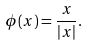<formula> <loc_0><loc_0><loc_500><loc_500>\phi ( x ) = \frac { x } { | x | } .</formula> 